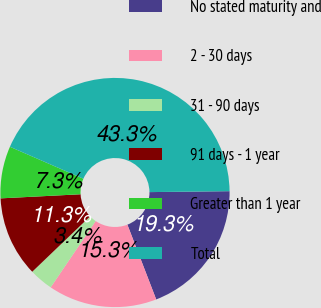<chart> <loc_0><loc_0><loc_500><loc_500><pie_chart><fcel>No stated maturity and<fcel>2 - 30 days<fcel>31 - 90 days<fcel>91 days - 1 year<fcel>Greater than 1 year<fcel>Total<nl><fcel>19.33%<fcel>15.34%<fcel>3.36%<fcel>11.34%<fcel>7.35%<fcel>43.28%<nl></chart> 